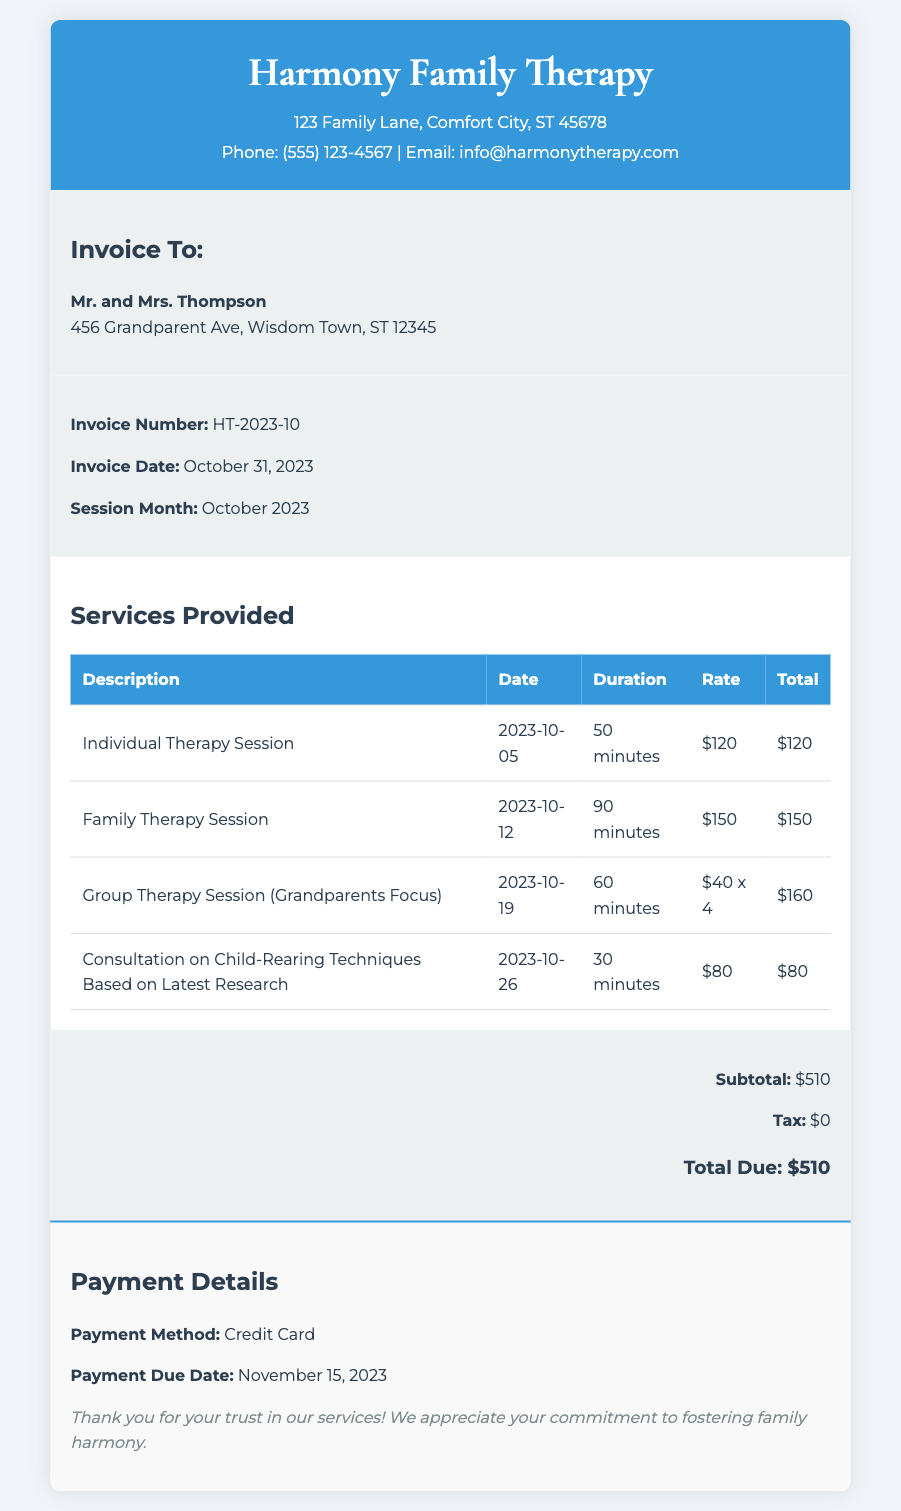What is the invoice number? The invoice number is listed under the invoice details section.
Answer: HT-2023-10 What are the names of the clients? The names of the clients are mentioned in the client details section.
Answer: Mr. and Mrs. Thompson What is the total due amount? The total due amount is summarized at the end of the invoice.
Answer: $510 How many therapy sessions were listed? The number of sessions can be counted from the services provided table.
Answer: 4 What was the date of the family therapy session? The date of the family therapy session is provided in the services section of the document.
Answer: 2023-10-12 Which payment method is used? The payment method is detailed in the payment details section.
Answer: Credit Card What was the duration of the individual therapy session? The duration is presented in the services table for the individual therapy session.
Answer: 50 minutes What is the payment due date? The payment due date is indicated in the payment details section.
Answer: November 15, 2023 What service focuses on grandparents? A specific session type is mentioned in the services table focusing on grandparents.
Answer: Group Therapy Session (Grandparents Focus) 